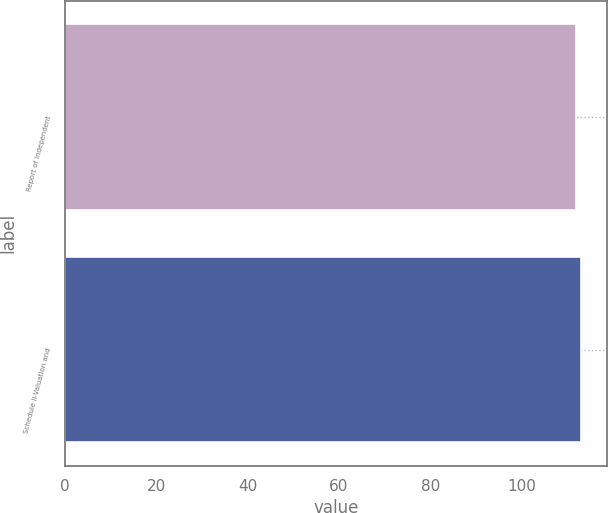Convert chart. <chart><loc_0><loc_0><loc_500><loc_500><bar_chart><fcel>Report of Independent<fcel>Schedule II-Valuation and<nl><fcel>112<fcel>113<nl></chart> 